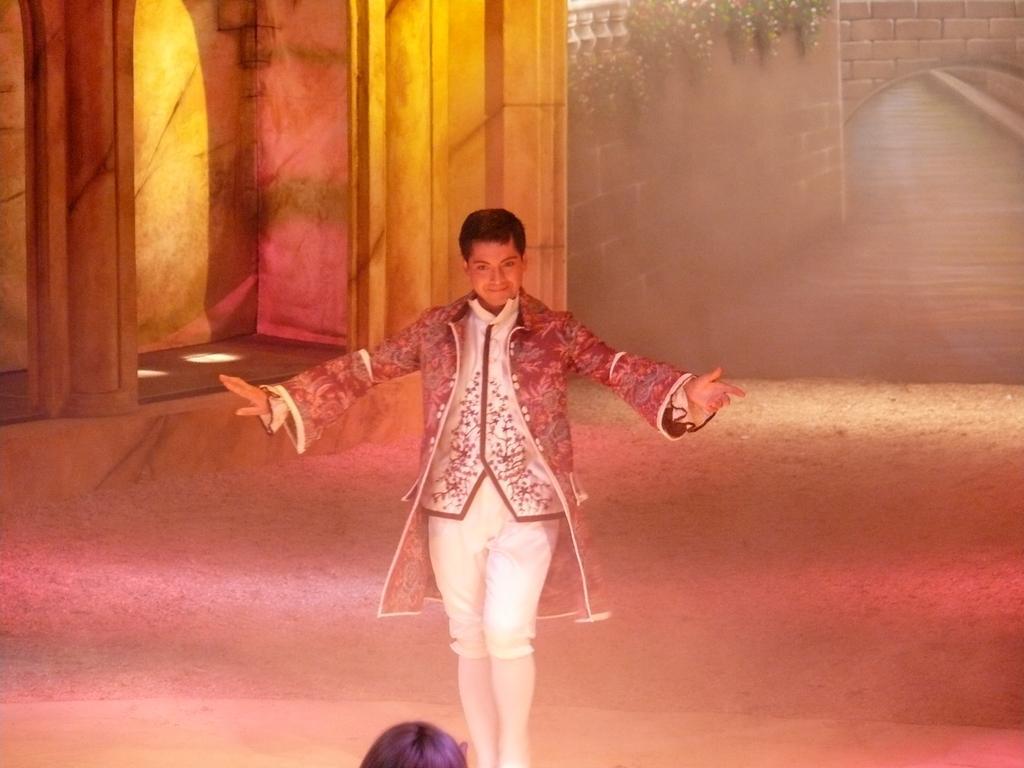How would you summarize this image in a sentence or two? In this image we can see two persons, among them one person is standing and the other person is truncated, there are pillars, creeper and the wall. 